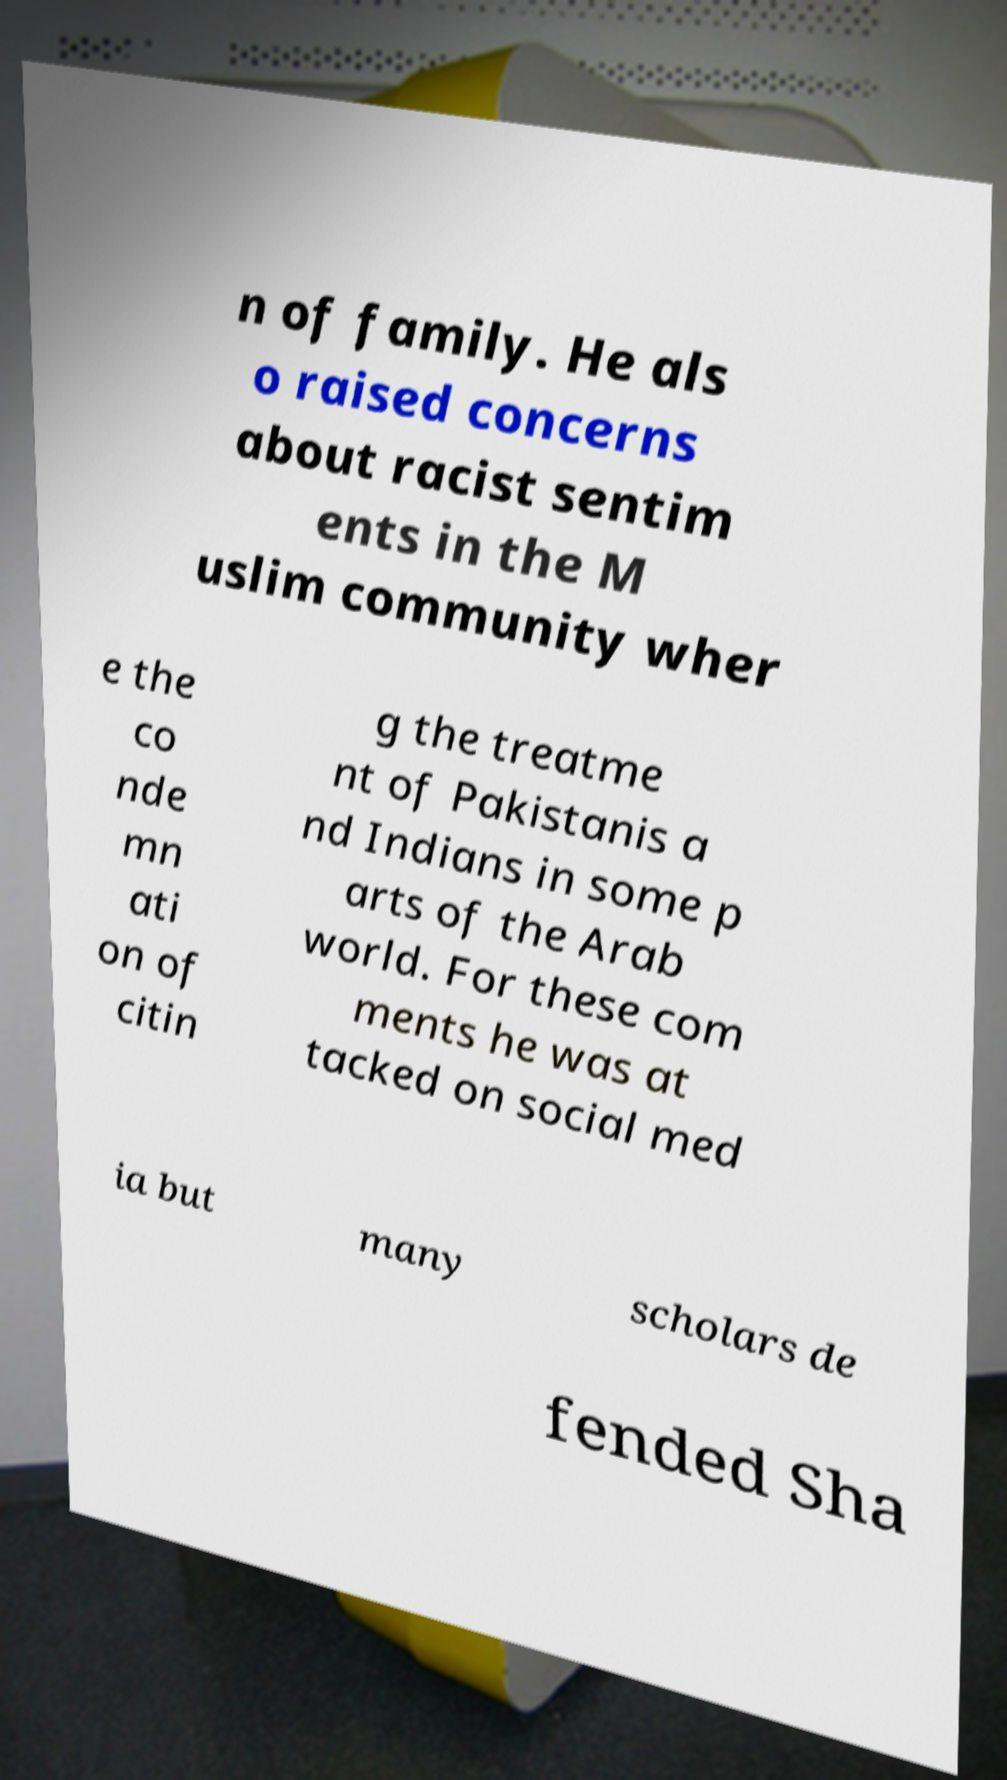There's text embedded in this image that I need extracted. Can you transcribe it verbatim? n of family. He als o raised concerns about racist sentim ents in the M uslim community wher e the co nde mn ati on of citin g the treatme nt of Pakistanis a nd Indians in some p arts of the Arab world. For these com ments he was at tacked on social med ia but many scholars de fended Sha 